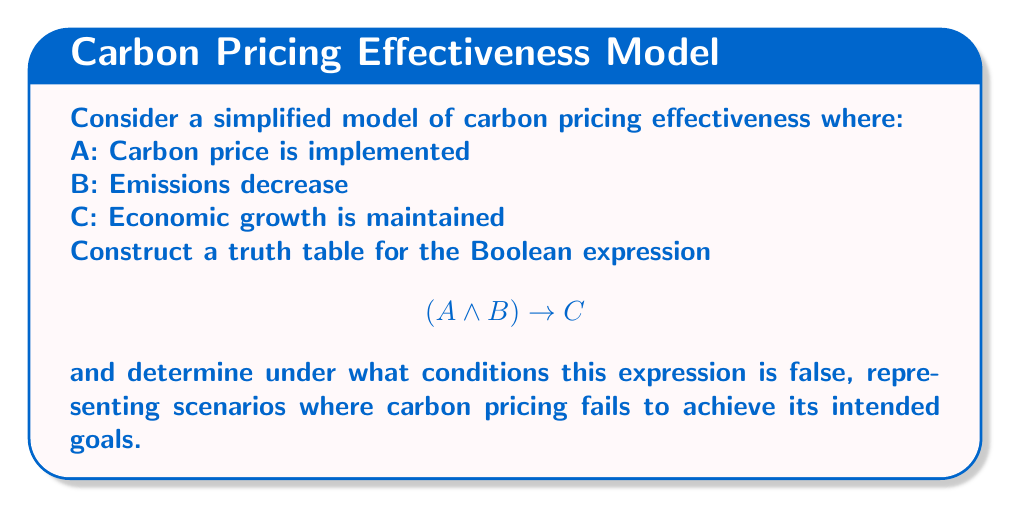Provide a solution to this math problem. To analyze this problem, we'll follow these steps:

1) First, let's construct the truth table for $(A \land B) \rightarrow C$:

   | A | B | C | A ∧ B | (A ∧ B) → C |
   |---|---|---|-------|-------------|
   | 0 | 0 | 0 |   0   |      1      |
   | 0 | 0 | 1 |   0   |      1      |
   | 0 | 1 | 0 |   0   |      1      |
   | 0 | 1 | 1 |   0   |      1      |
   | 1 | 0 | 0 |   0   |      1      |
   | 1 | 0 | 1 |   0   |      1      |
   | 1 | 1 | 0 |   1   |      0      |
   | 1 | 1 | 1 |   1   |      1      |

2) The expression $(A \land B) \rightarrow C$ is equivalent to "If carbon pricing is implemented AND emissions decrease, THEN economic growth is maintained."

3) This expression is false only when $(A \land B)$ is true and $C$ is false. This occurs in the second-to-last row of the truth table.

4) In Boolean terms, the condition for the expression to be false is:

   $A \land B \land \lnot C$

5) Interpreting this result in the context of carbon pricing:
   The carbon pricing mechanism fails when carbon pricing is implemented (A is true) AND emissions decrease (B is true), but economic growth is not maintained (C is false).

This analysis helps identify the critical scenario where carbon pricing may be considered ineffective: when it successfully reduces emissions but at the cost of economic growth.
Answer: $A \land B \land \lnot C$ 